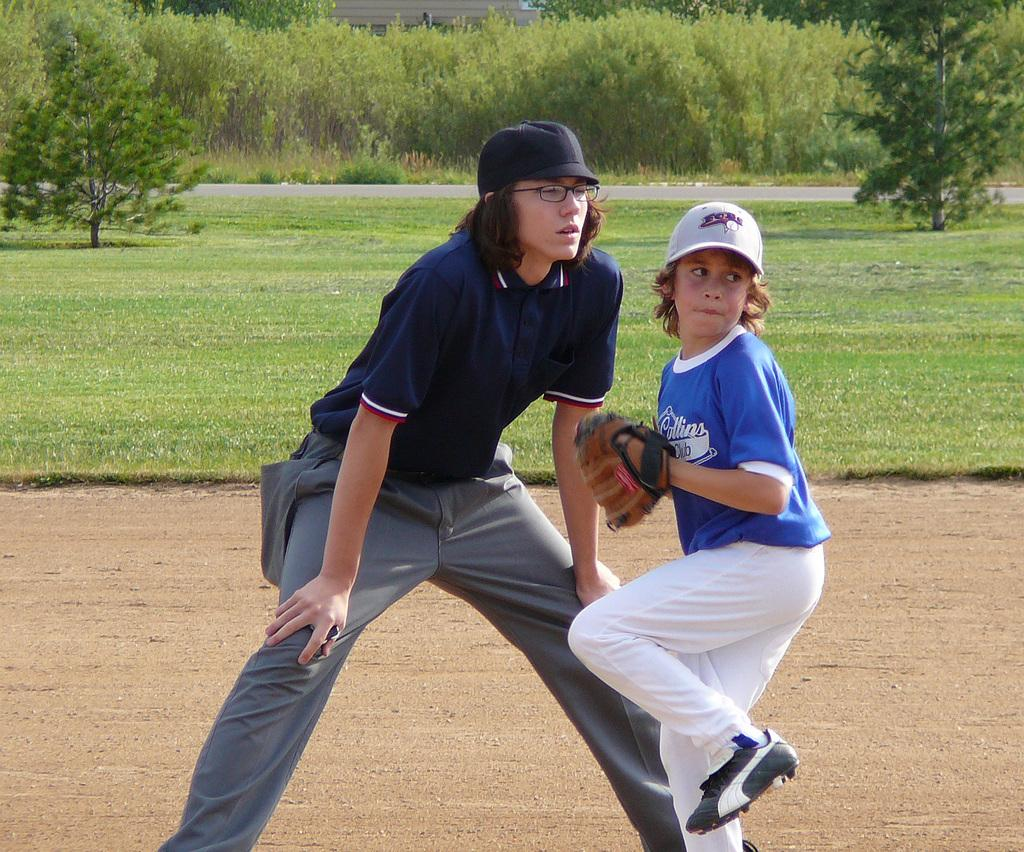What type of road is visible at the bottom of the image? There is a mud road at the bottom of the image. How many people can be seen in the foreground of the image? There are two people in the foreground of the image. What type of vegetation is present in the background of the image? There is green grass in the background of the image. What other features can be seen in the background of the image? There are trees and a building in the background of the image. Are there any houses in the image that are being used as a slave labor camp? There is no mention of houses, slave labor, or any camp in the image. The image features a mud road, two people in the foreground, and green grass, trees, and a building in the background. 